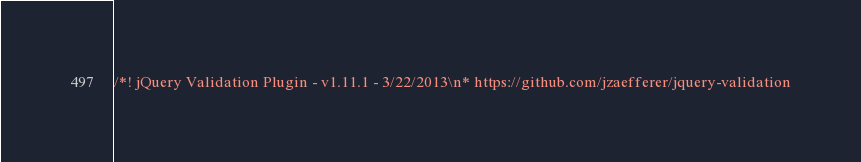<code> <loc_0><loc_0><loc_500><loc_500><_JavaScript_>/*! jQuery Validation Plugin - v1.11.1 - 3/22/2013\n* https://github.com/jzaefferer/jquery-validation</code> 